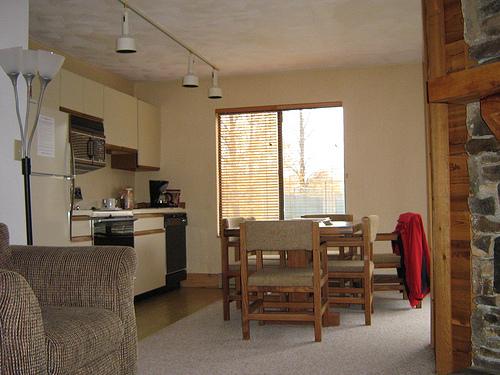Was it taken at night?
Write a very short answer. No. Are the lights on?
Be succinct. No. Is the kitchen and living room in one?
Concise answer only. Yes. Was this picture taken in the daytime?
Quick response, please. Yes. What sort of blind is covering the window?
Write a very short answer. Wood. How many fixtures in the ceiling?
Keep it brief. 3. Are the tables wooden?
Short answer required. Yes. Does the kitchen have a dishwasher?
Write a very short answer. Yes. Does the rug have fringes?
Quick response, please. No. What type of flooring is on the right side of the house?
Concise answer only. Carpet. Does this place look cluttered?
Concise answer only. No. How many places are there to sit down?
Give a very brief answer. 5. 